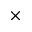<formula> <loc_0><loc_0><loc_500><loc_500>\times</formula> 